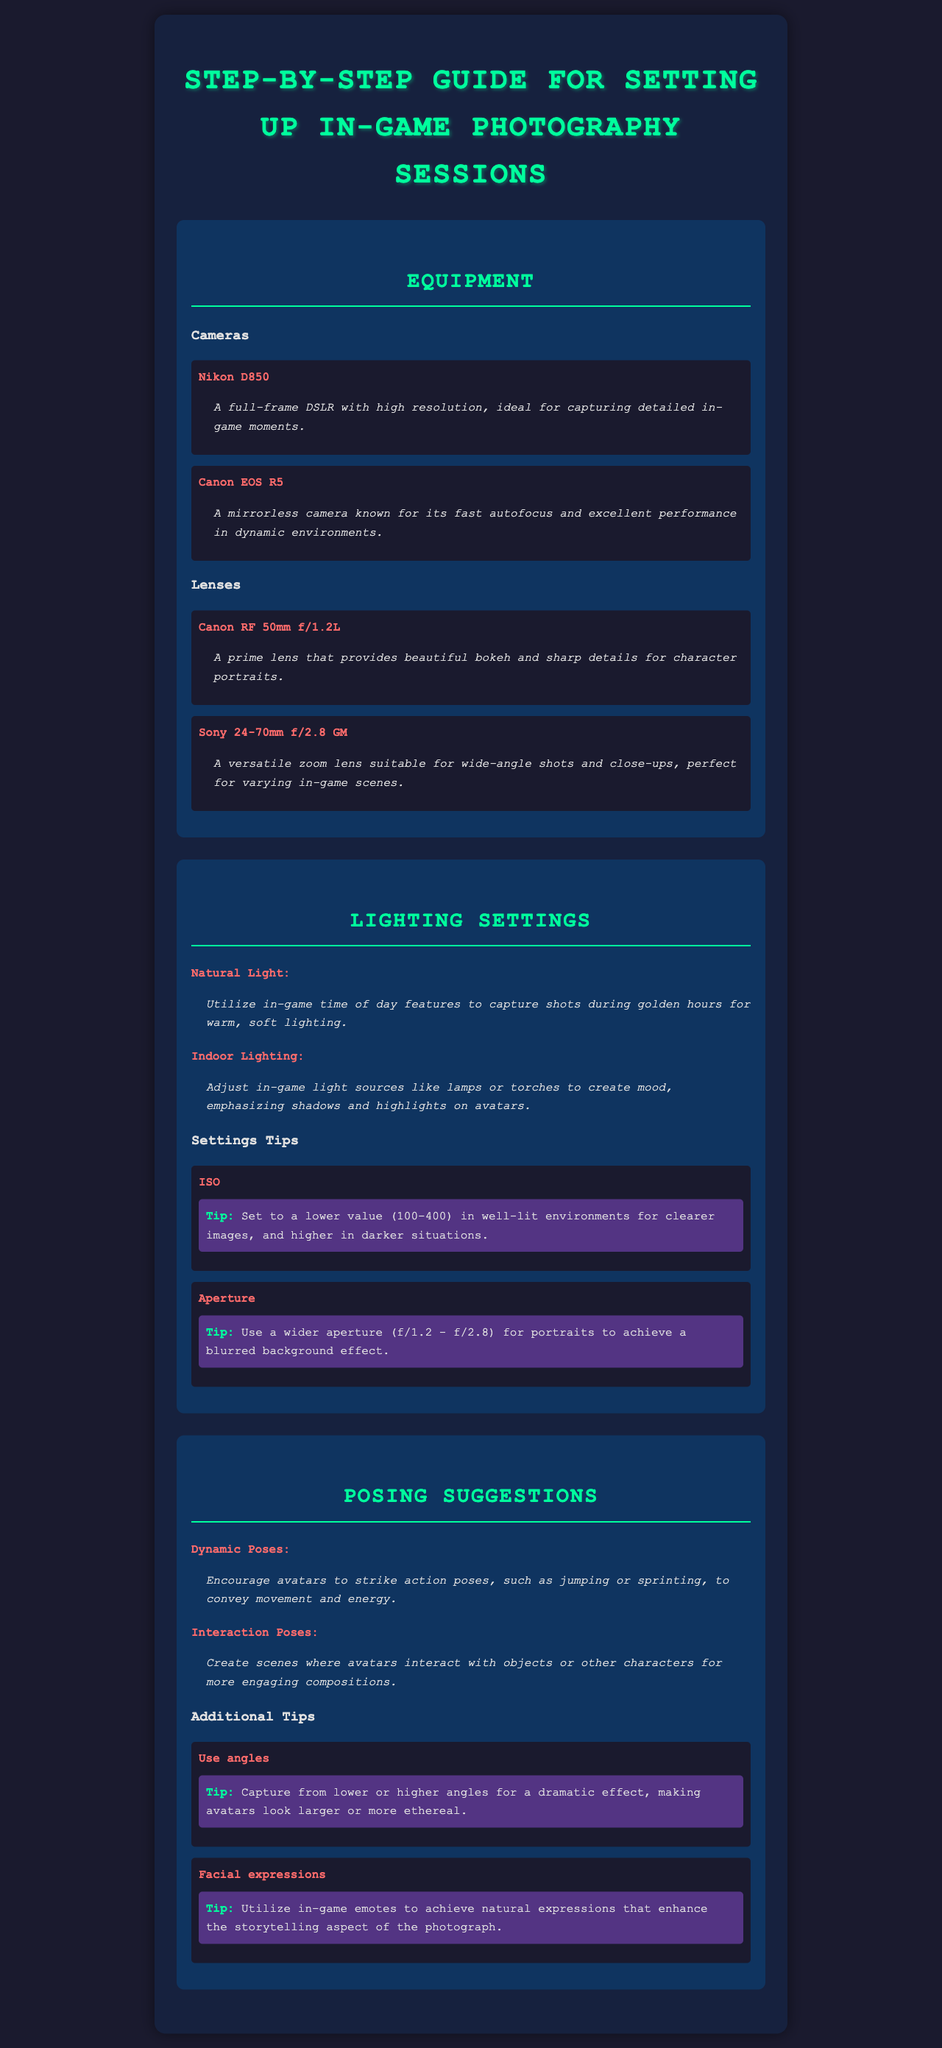What type of camera is the Nikon D850? The Nikon D850 is classified as a full-frame DSLR according to the document.
Answer: full-frame DSLR What aperture is recommended for portraits? The document suggests using a wider aperture for portraits, specifically mentioning f/1.2 - f/2.8.
Answer: f/1.2 - f/2.8 What is a benefit of using the Canon RF 50mm f/1.2L lens? The document states that this lens provides beautiful bokeh and sharp details for character portraits.
Answer: beautiful bokeh and sharp details What should you adjust for creating mood indoors? The document recommends adjusting in-game light sources like lamps or torches.
Answer: adjust in-game light sources What is a suggestion for dynamic posing? One suggestion in the document is to encourage avatars to strike action poses, such as jumping or sprinting.
Answer: action poses, such as jumping or sprinting How many lighting settings are detailed in the guide? The document lists two specific lighting settings under "Lighting Settings."
Answer: 2 What camera is known for excellent performance in dynamic environments? The Canon EOS R5 is acknowledged in the document for its excellent performance in dynamic environments.
Answer: Canon EOS R5 What technique enhances the storytelling aspect of photographs? Utilizing in-game emotes to achieve natural expressions is a technique mentioned for enhancing storytelling.
Answer: using in-game emotes 